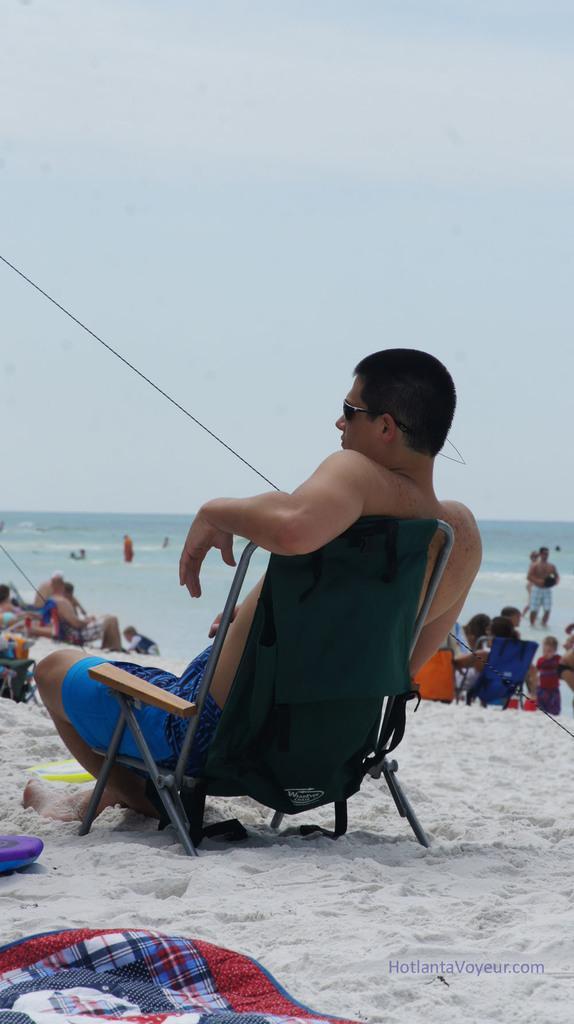Can you describe this image briefly? In this image in the foreground there is one person who is sitting on chair. At the bottom there is sand and on the sand there are some clothes, in the background there are a group of people and a beach. 